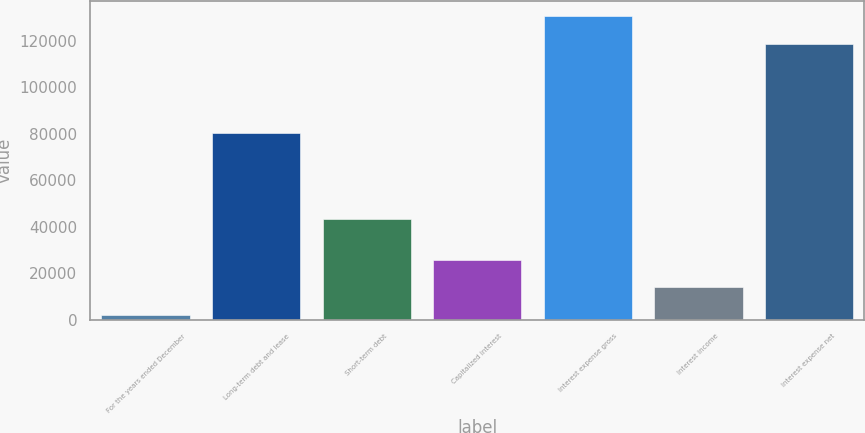<chart> <loc_0><loc_0><loc_500><loc_500><bar_chart><fcel>For the years ended December<fcel>Long-term debt and lease<fcel>Short-term debt<fcel>Capitalized interest<fcel>Interest expense gross<fcel>Interest income<fcel>Interest expense net<nl><fcel>2007<fcel>80351<fcel>43485<fcel>25818.8<fcel>130491<fcel>13912.9<fcel>118585<nl></chart> 